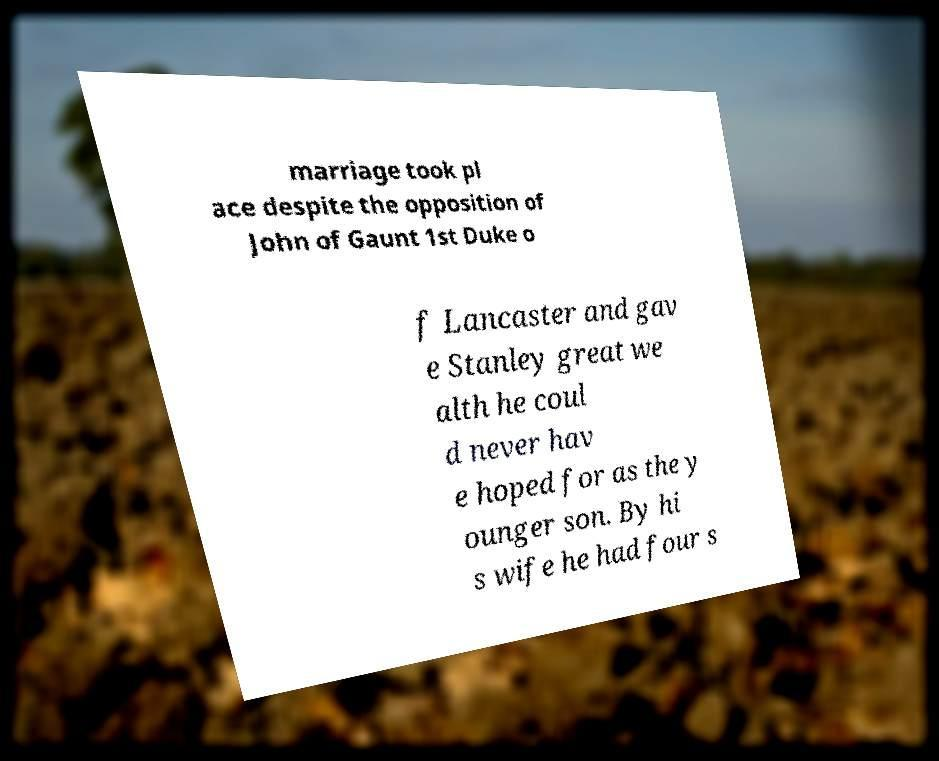Please read and relay the text visible in this image. What does it say? marriage took pl ace despite the opposition of John of Gaunt 1st Duke o f Lancaster and gav e Stanley great we alth he coul d never hav e hoped for as the y ounger son. By hi s wife he had four s 